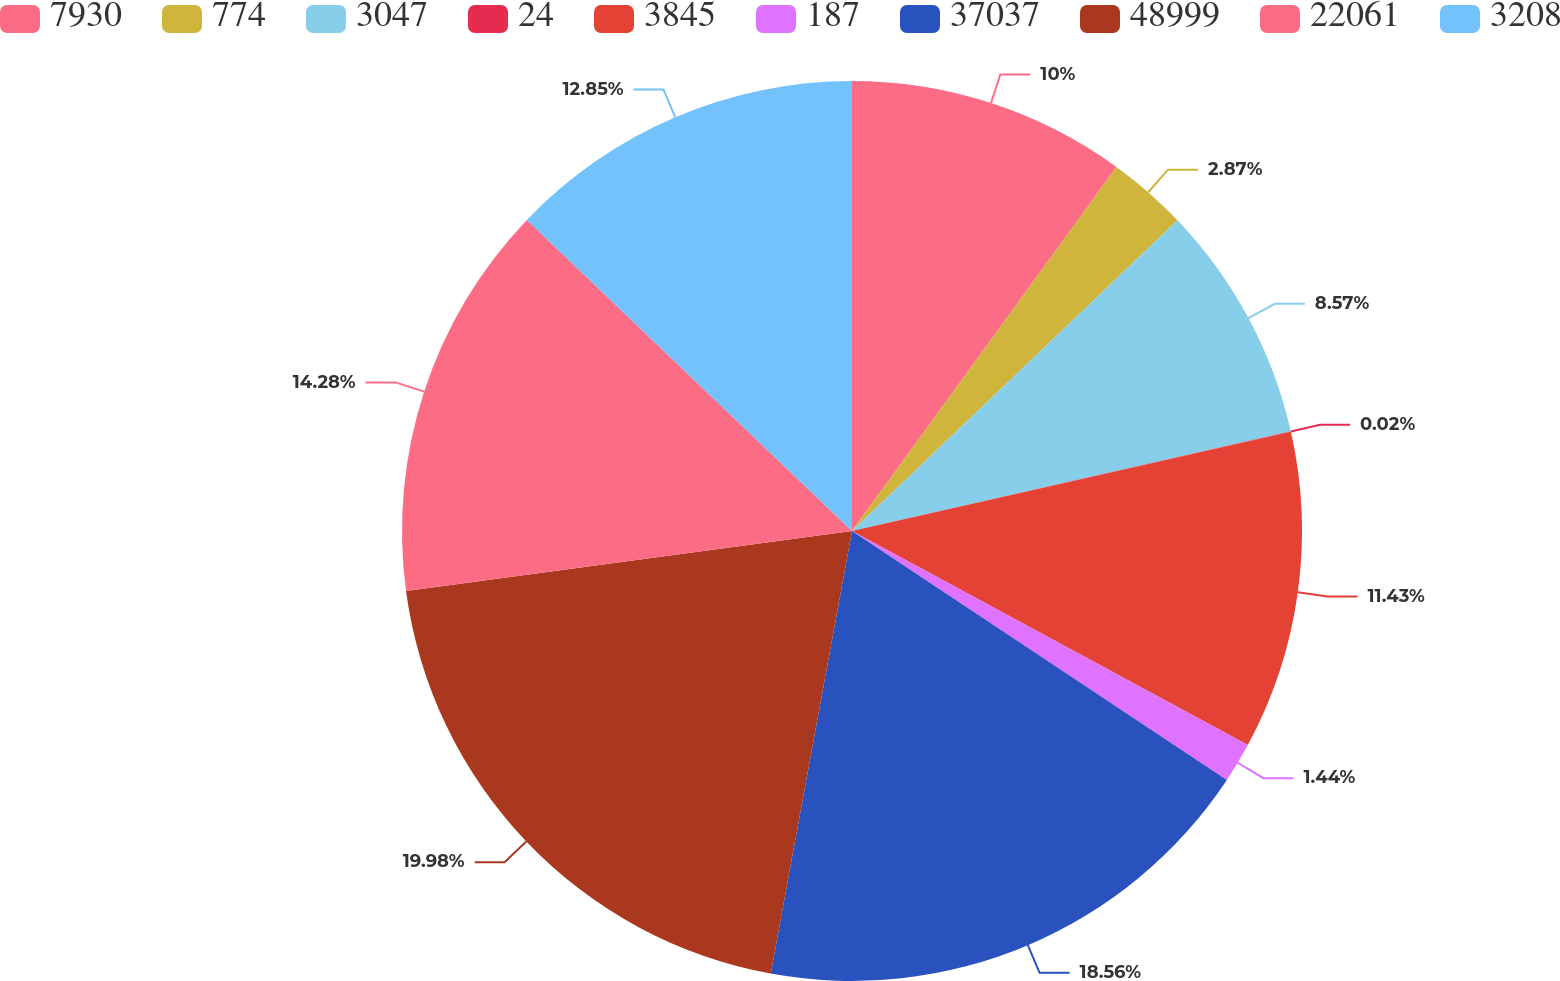Convert chart to OTSL. <chart><loc_0><loc_0><loc_500><loc_500><pie_chart><fcel>7930<fcel>774<fcel>3047<fcel>24<fcel>3845<fcel>187<fcel>37037<fcel>48999<fcel>22061<fcel>3208<nl><fcel>10.0%<fcel>2.87%<fcel>8.57%<fcel>0.02%<fcel>11.43%<fcel>1.44%<fcel>18.56%<fcel>19.98%<fcel>14.28%<fcel>12.85%<nl></chart> 